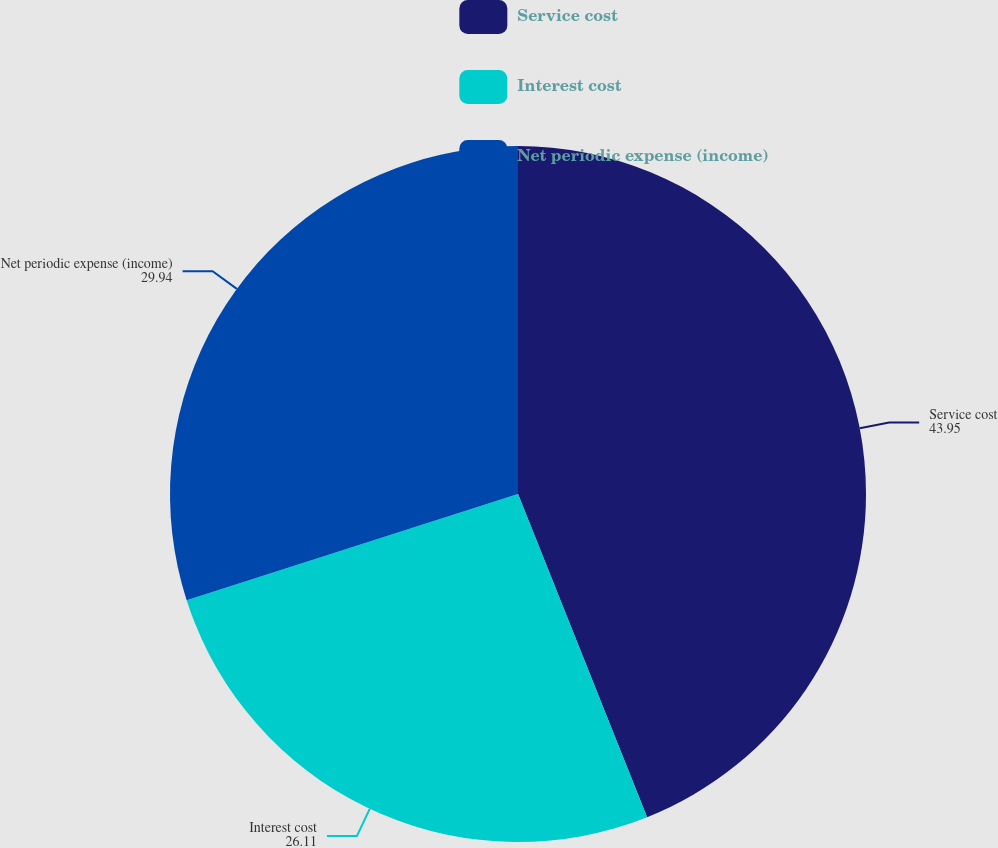Convert chart. <chart><loc_0><loc_0><loc_500><loc_500><pie_chart><fcel>Service cost<fcel>Interest cost<fcel>Net periodic expense (income)<nl><fcel>43.95%<fcel>26.11%<fcel>29.94%<nl></chart> 